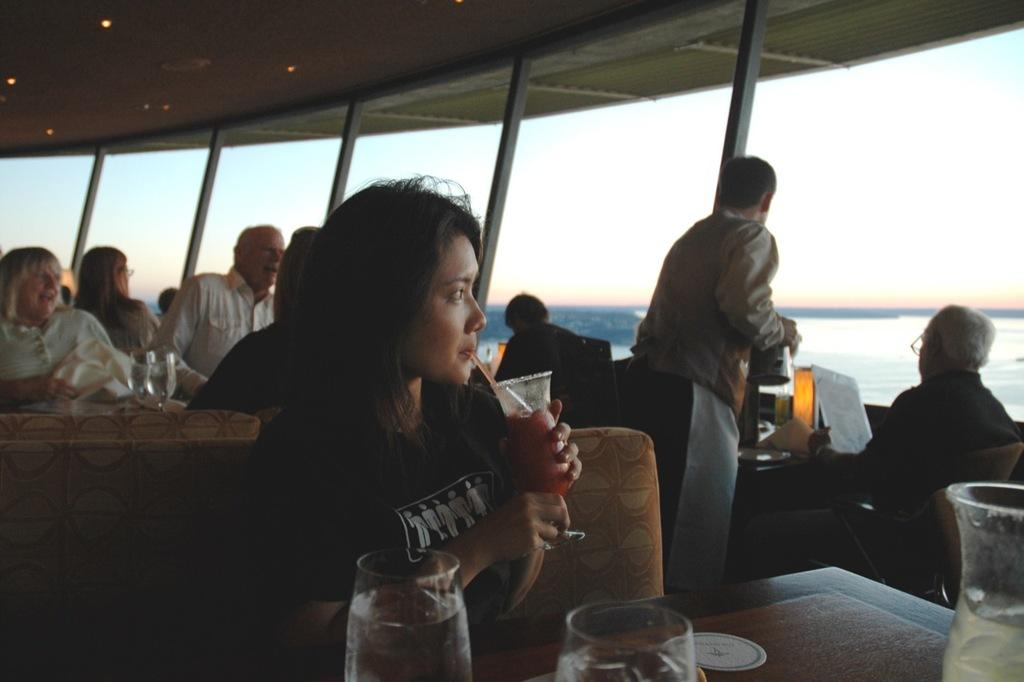How many people are in the image? There is a group of people in the image, but the exact number is not specified. What objects can be seen in the image? There are glasses, tables, chairs, paper, a shelter, and some other objects in the image. What can be seen in the background of the image? Water and sky are visible in the background of the image. How many goats are present in the image? There are no goats present in the image. What detail is missing from the image that the group of people might need? The provided facts do not indicate any missing details or needs of the group of people in the image. 